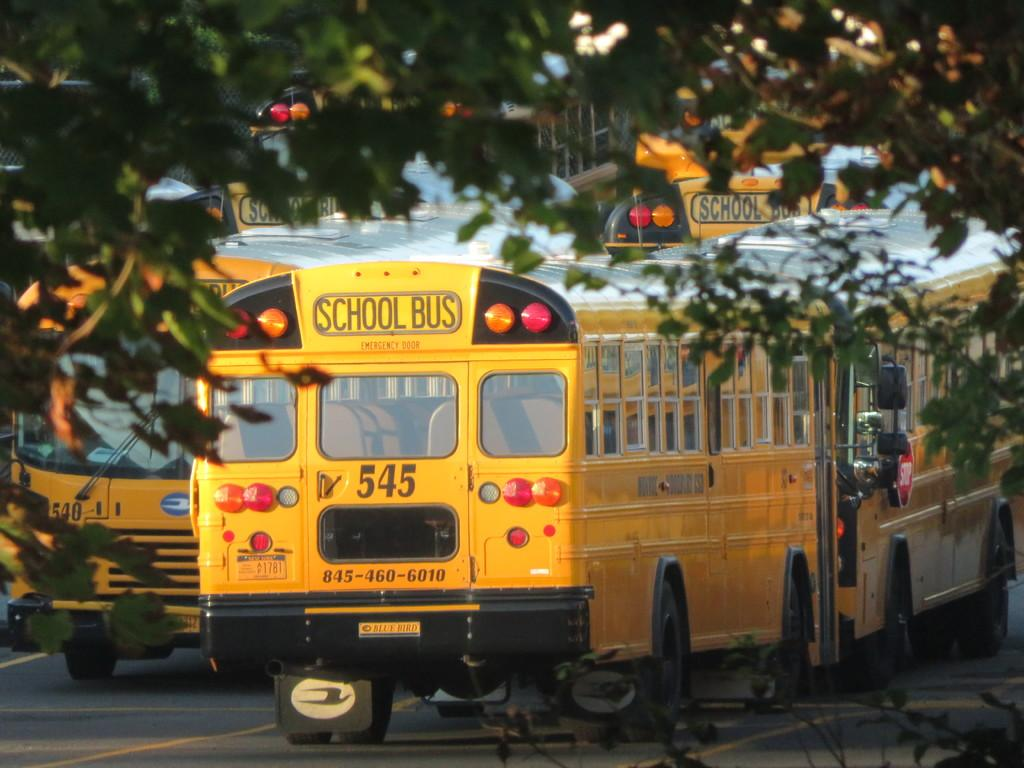What type of vehicles are in the image? There are school buses in the image. What color are the school buses? The school buses are yellow. What is at the bottom of the image? There is a road at the bottom of the image. What can be seen at the top of the image? There is a tree visible at the top of the image. What month is it in the image? The month cannot be determined from the image, as there is no information about the time of year. 